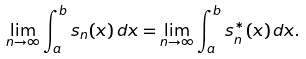Convert formula to latex. <formula><loc_0><loc_0><loc_500><loc_500>\lim _ { n \rightarrow \infty } \int _ { a } ^ { b } s _ { n } ( x ) \, d x = \lim _ { n \rightarrow \infty } \int _ { a } ^ { b } s _ { n } ^ { * } ( x ) \, d x .</formula> 